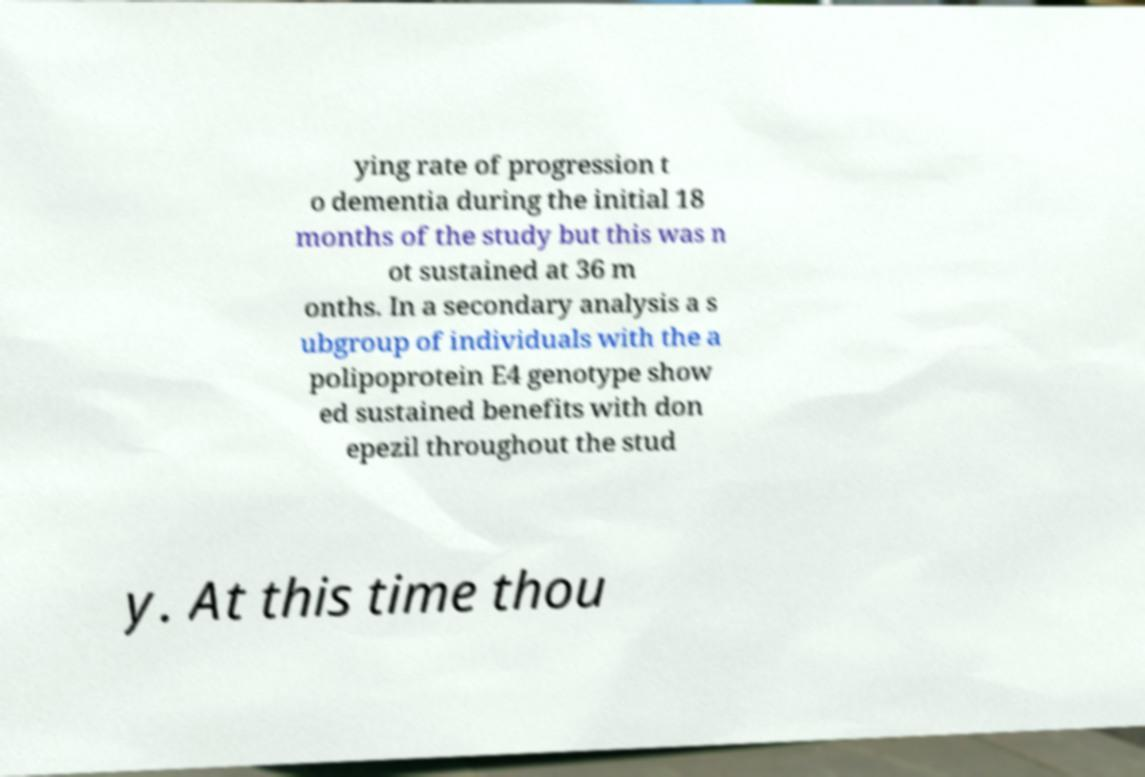I need the written content from this picture converted into text. Can you do that? ying rate of progression t o dementia during the initial 18 months of the study but this was n ot sustained at 36 m onths. In a secondary analysis a s ubgroup of individuals with the a polipoprotein E4 genotype show ed sustained benefits with don epezil throughout the stud y. At this time thou 